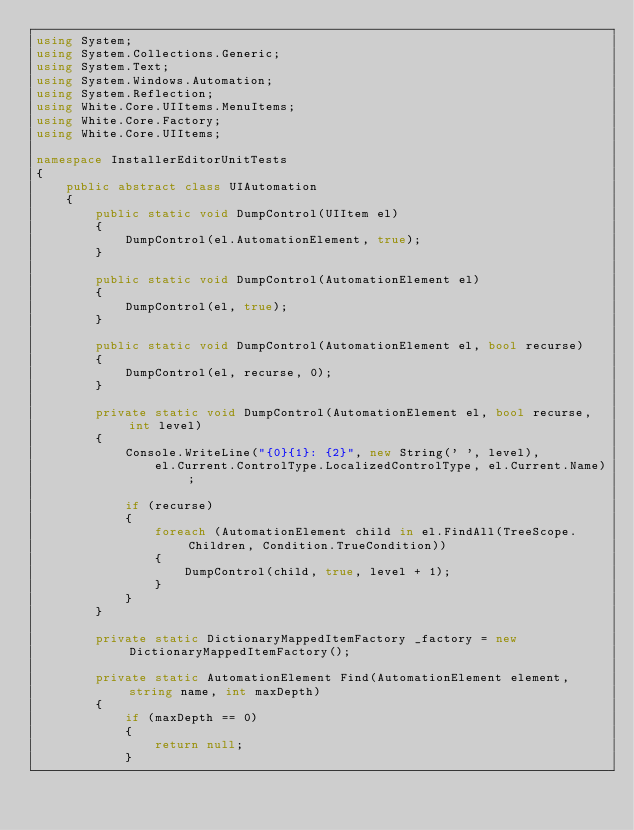Convert code to text. <code><loc_0><loc_0><loc_500><loc_500><_C#_>using System;
using System.Collections.Generic;
using System.Text;
using System.Windows.Automation;
using System.Reflection;
using White.Core.UIItems.MenuItems;
using White.Core.Factory;
using White.Core.UIItems;

namespace InstallerEditorUnitTests
{
    public abstract class UIAutomation
    {
        public static void DumpControl(UIItem el)
        {
            DumpControl(el.AutomationElement, true);
        }

        public static void DumpControl(AutomationElement el)
        {
            DumpControl(el, true);
        }

        public static void DumpControl(AutomationElement el, bool recurse)
        {
            DumpControl(el, recurse, 0);
        }

        private static void DumpControl(AutomationElement el, bool recurse, int level)
        {
            Console.WriteLine("{0}{1}: {2}", new String(' ', level),
                el.Current.ControlType.LocalizedControlType, el.Current.Name);

            if (recurse)
            {
                foreach (AutomationElement child in el.FindAll(TreeScope.Children, Condition.TrueCondition))
                {
                    DumpControl(child, true, level + 1);
                }
            }
        }

        private static DictionaryMappedItemFactory _factory = new DictionaryMappedItemFactory();

        private static AutomationElement Find(AutomationElement element, string name, int maxDepth)
        {
            if (maxDepth == 0)
            {
                return null;
            }</code> 